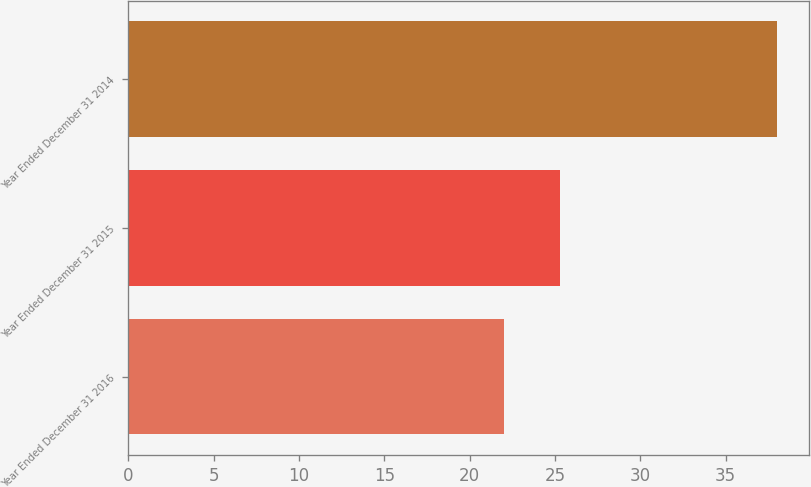Convert chart. <chart><loc_0><loc_0><loc_500><loc_500><bar_chart><fcel>Year Ended December 31 2016<fcel>Year Ended December 31 2015<fcel>Year Ended December 31 2014<nl><fcel>22<fcel>25.3<fcel>38<nl></chart> 